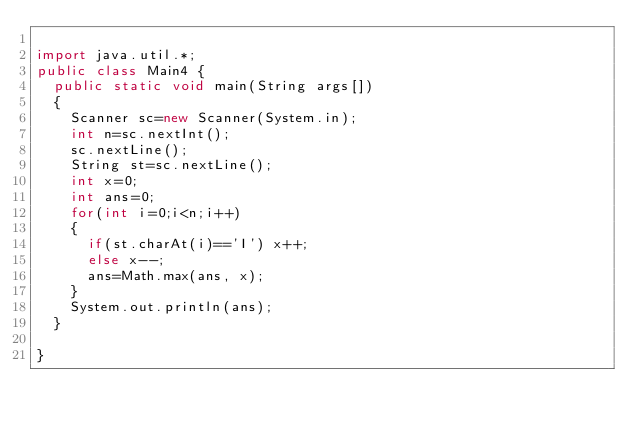<code> <loc_0><loc_0><loc_500><loc_500><_Java_>
import java.util.*;
public class Main4 {
	public static void main(String args[])
	{
		Scanner sc=new Scanner(System.in);
		int n=sc.nextInt();
		sc.nextLine();
		String st=sc.nextLine();
		int x=0;
		int ans=0;
		for(int i=0;i<n;i++)
		{
			if(st.charAt(i)=='I') x++;
			else x--;
			ans=Math.max(ans, x);
		}
		System.out.println(ans);
	}

}
</code> 